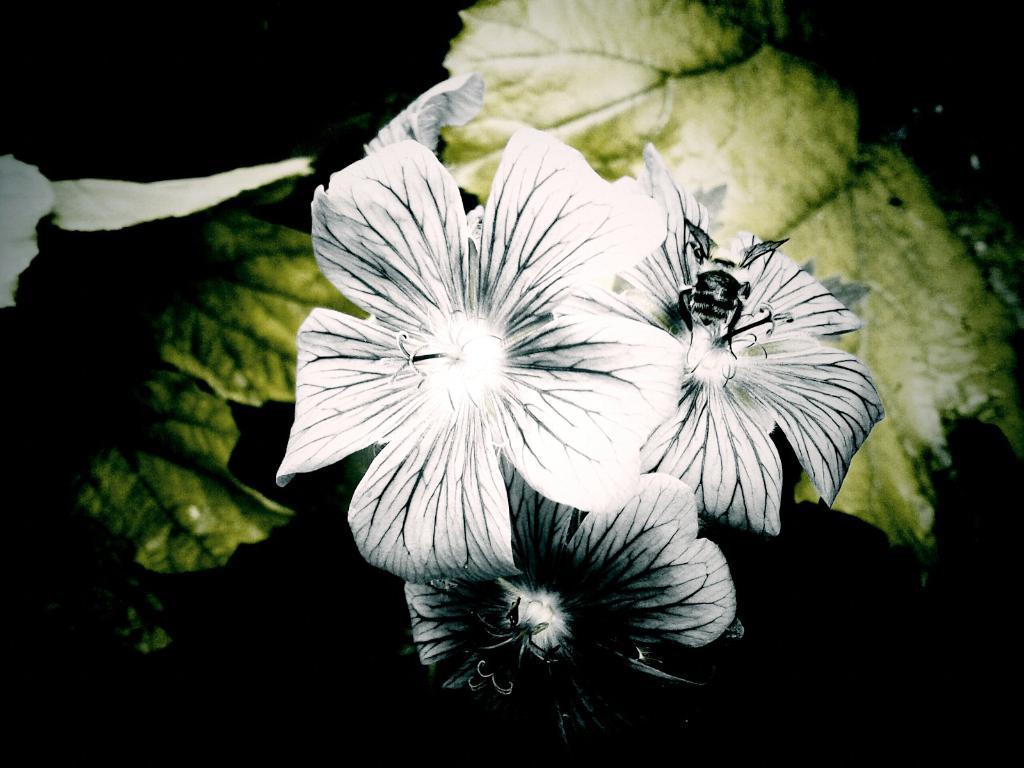How would you summarize this image in a sentence or two? In the picture we can see leaves and three flowers on it and the flowers are white in color with black color lines on it. 